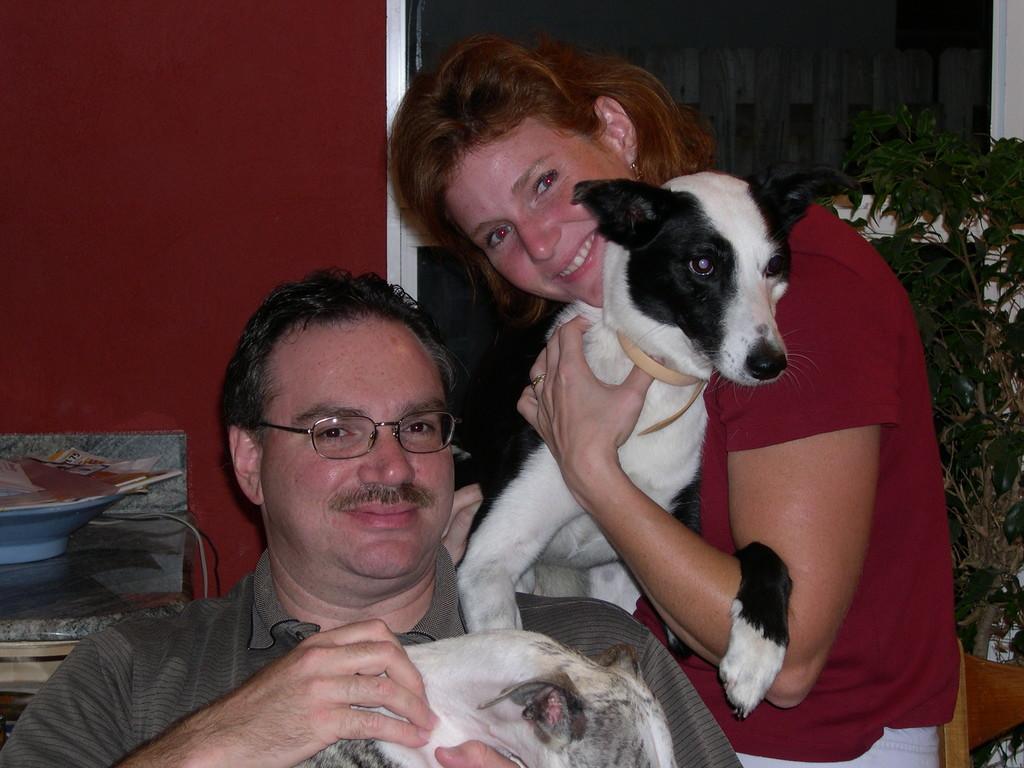Please provide a concise description of this image. In the image there are two people the woman is holding a dog and smiling and the man is holding another animal, behind them on the right side there is a plant in front of the window and on the left side there is some object kept on a surface. 